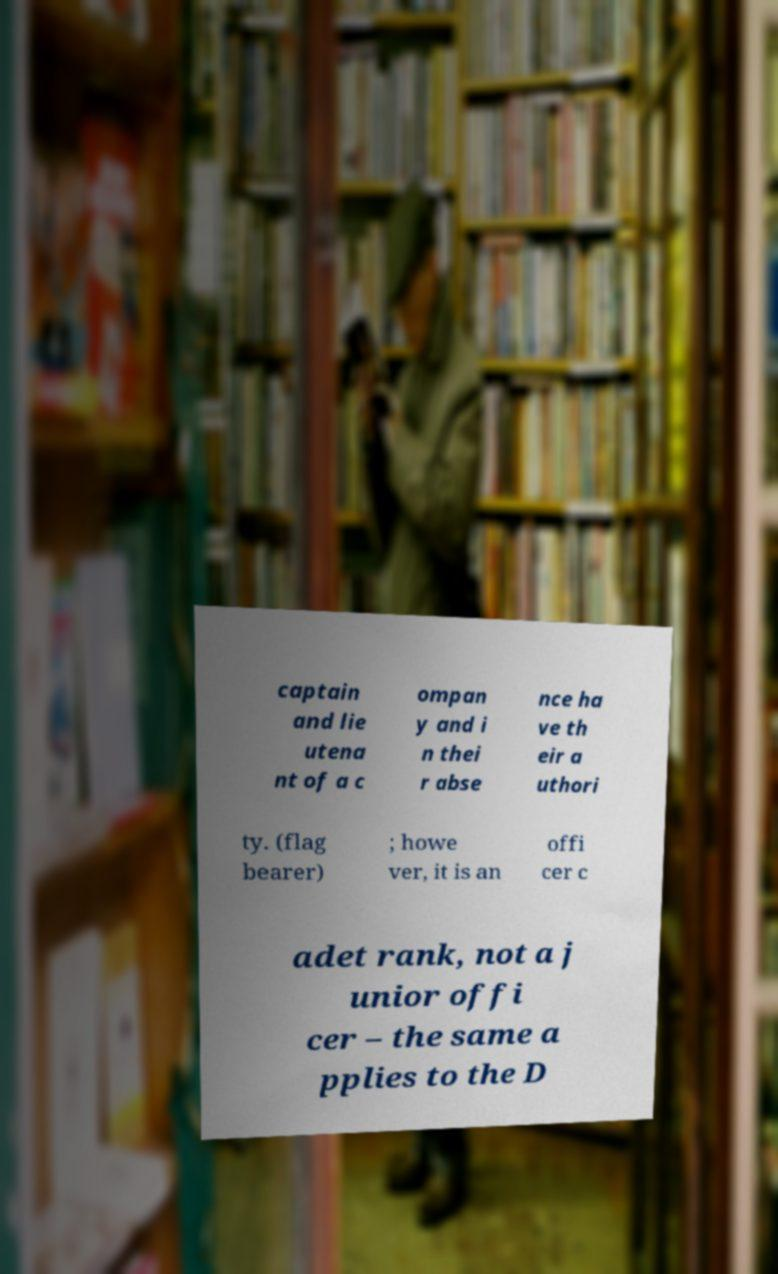What messages or text are displayed in this image? I need them in a readable, typed format. captain and lie utena nt of a c ompan y and i n thei r abse nce ha ve th eir a uthori ty. (flag bearer) ; howe ver, it is an offi cer c adet rank, not a j unior offi cer – the same a pplies to the D 